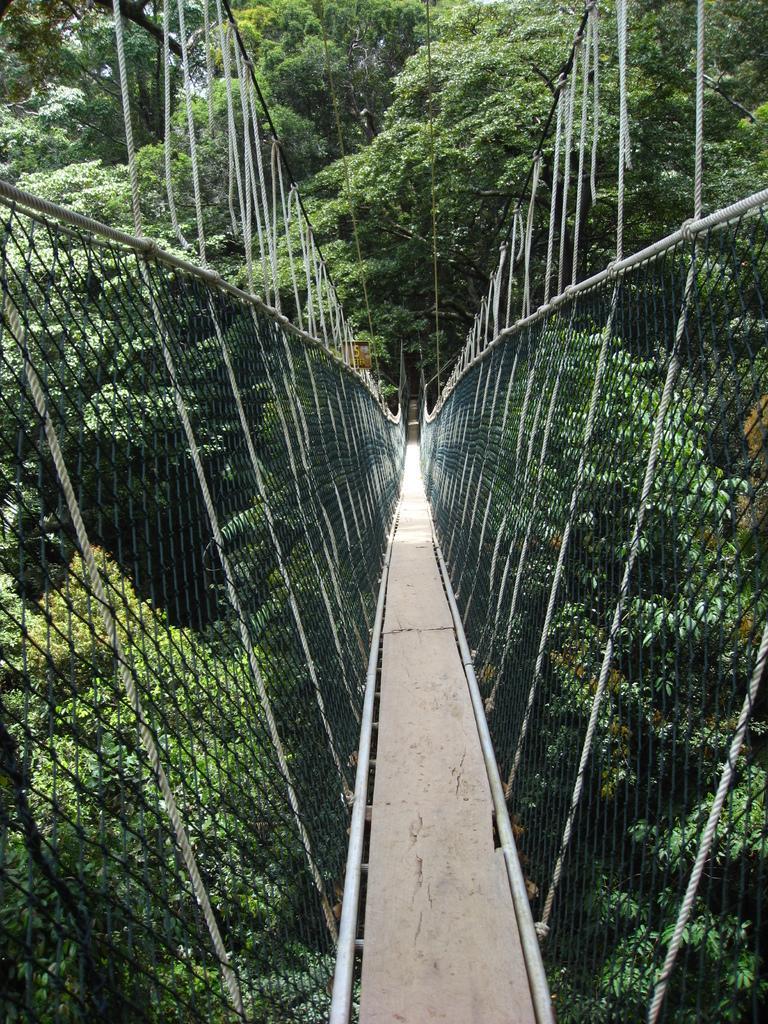Can you describe this image briefly? In the picture I can see a bridge. In the background I can see trees. The bridge have nets on both sides. 